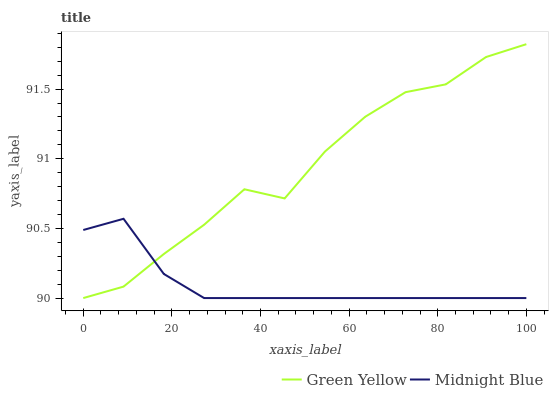Does Midnight Blue have the minimum area under the curve?
Answer yes or no. Yes. Does Green Yellow have the maximum area under the curve?
Answer yes or no. Yes. Does Midnight Blue have the maximum area under the curve?
Answer yes or no. No. Is Midnight Blue the smoothest?
Answer yes or no. Yes. Is Green Yellow the roughest?
Answer yes or no. Yes. Is Midnight Blue the roughest?
Answer yes or no. No. Does Green Yellow have the lowest value?
Answer yes or no. Yes. Does Green Yellow have the highest value?
Answer yes or no. Yes. Does Midnight Blue have the highest value?
Answer yes or no. No. Does Green Yellow intersect Midnight Blue?
Answer yes or no. Yes. Is Green Yellow less than Midnight Blue?
Answer yes or no. No. Is Green Yellow greater than Midnight Blue?
Answer yes or no. No. 